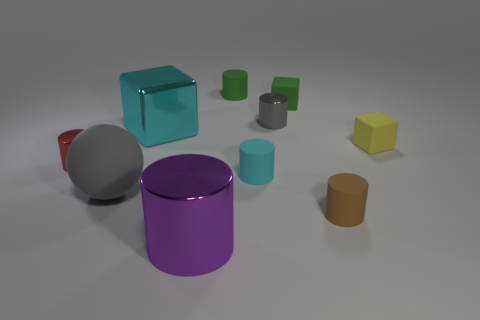Subtract 1 cylinders. How many cylinders are left? 5 Subtract all purple shiny cylinders. How many cylinders are left? 5 Subtract all red cylinders. How many cylinders are left? 5 Subtract all brown cylinders. Subtract all brown blocks. How many cylinders are left? 5 Subtract all cylinders. How many objects are left? 4 Add 7 gray cylinders. How many gray cylinders are left? 8 Add 3 big blue matte blocks. How many big blue matte blocks exist? 3 Subtract 1 purple cylinders. How many objects are left? 9 Subtract all brown shiny objects. Subtract all gray rubber spheres. How many objects are left? 9 